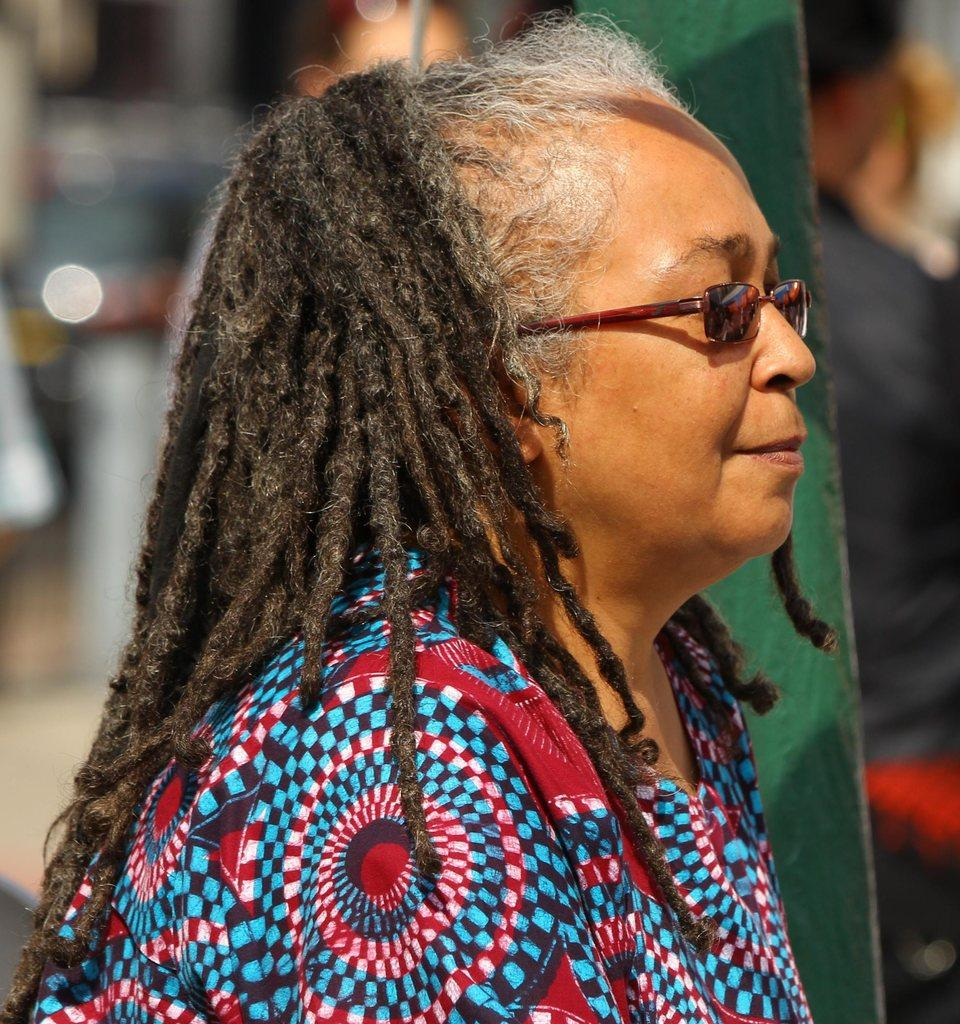Who is the main subject in the image? There is a lady in the center of the image. What is the lady wearing on her face? The lady is wearing spectacles. What type of clothing is the lady wearing? The lady is wearing a dress. What can be seen on the right side of the image? There is a pole on the right side of the image. How would you describe the background of the image? The background of the image is blurry. What type of box can be seen on the coast in the image? There is no box or coast present in the image; it features a lady in the center with a blurry background. 